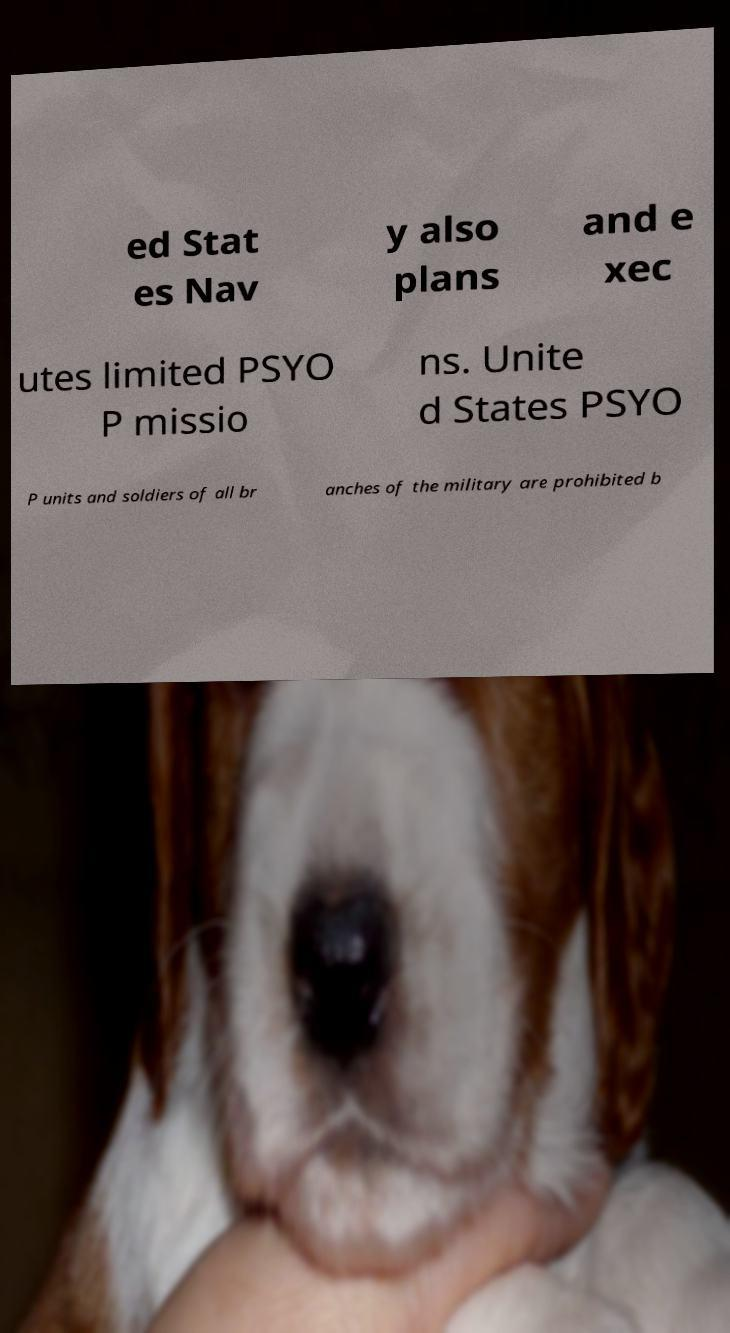For documentation purposes, I need the text within this image transcribed. Could you provide that? ed Stat es Nav y also plans and e xec utes limited PSYO P missio ns. Unite d States PSYO P units and soldiers of all br anches of the military are prohibited b 